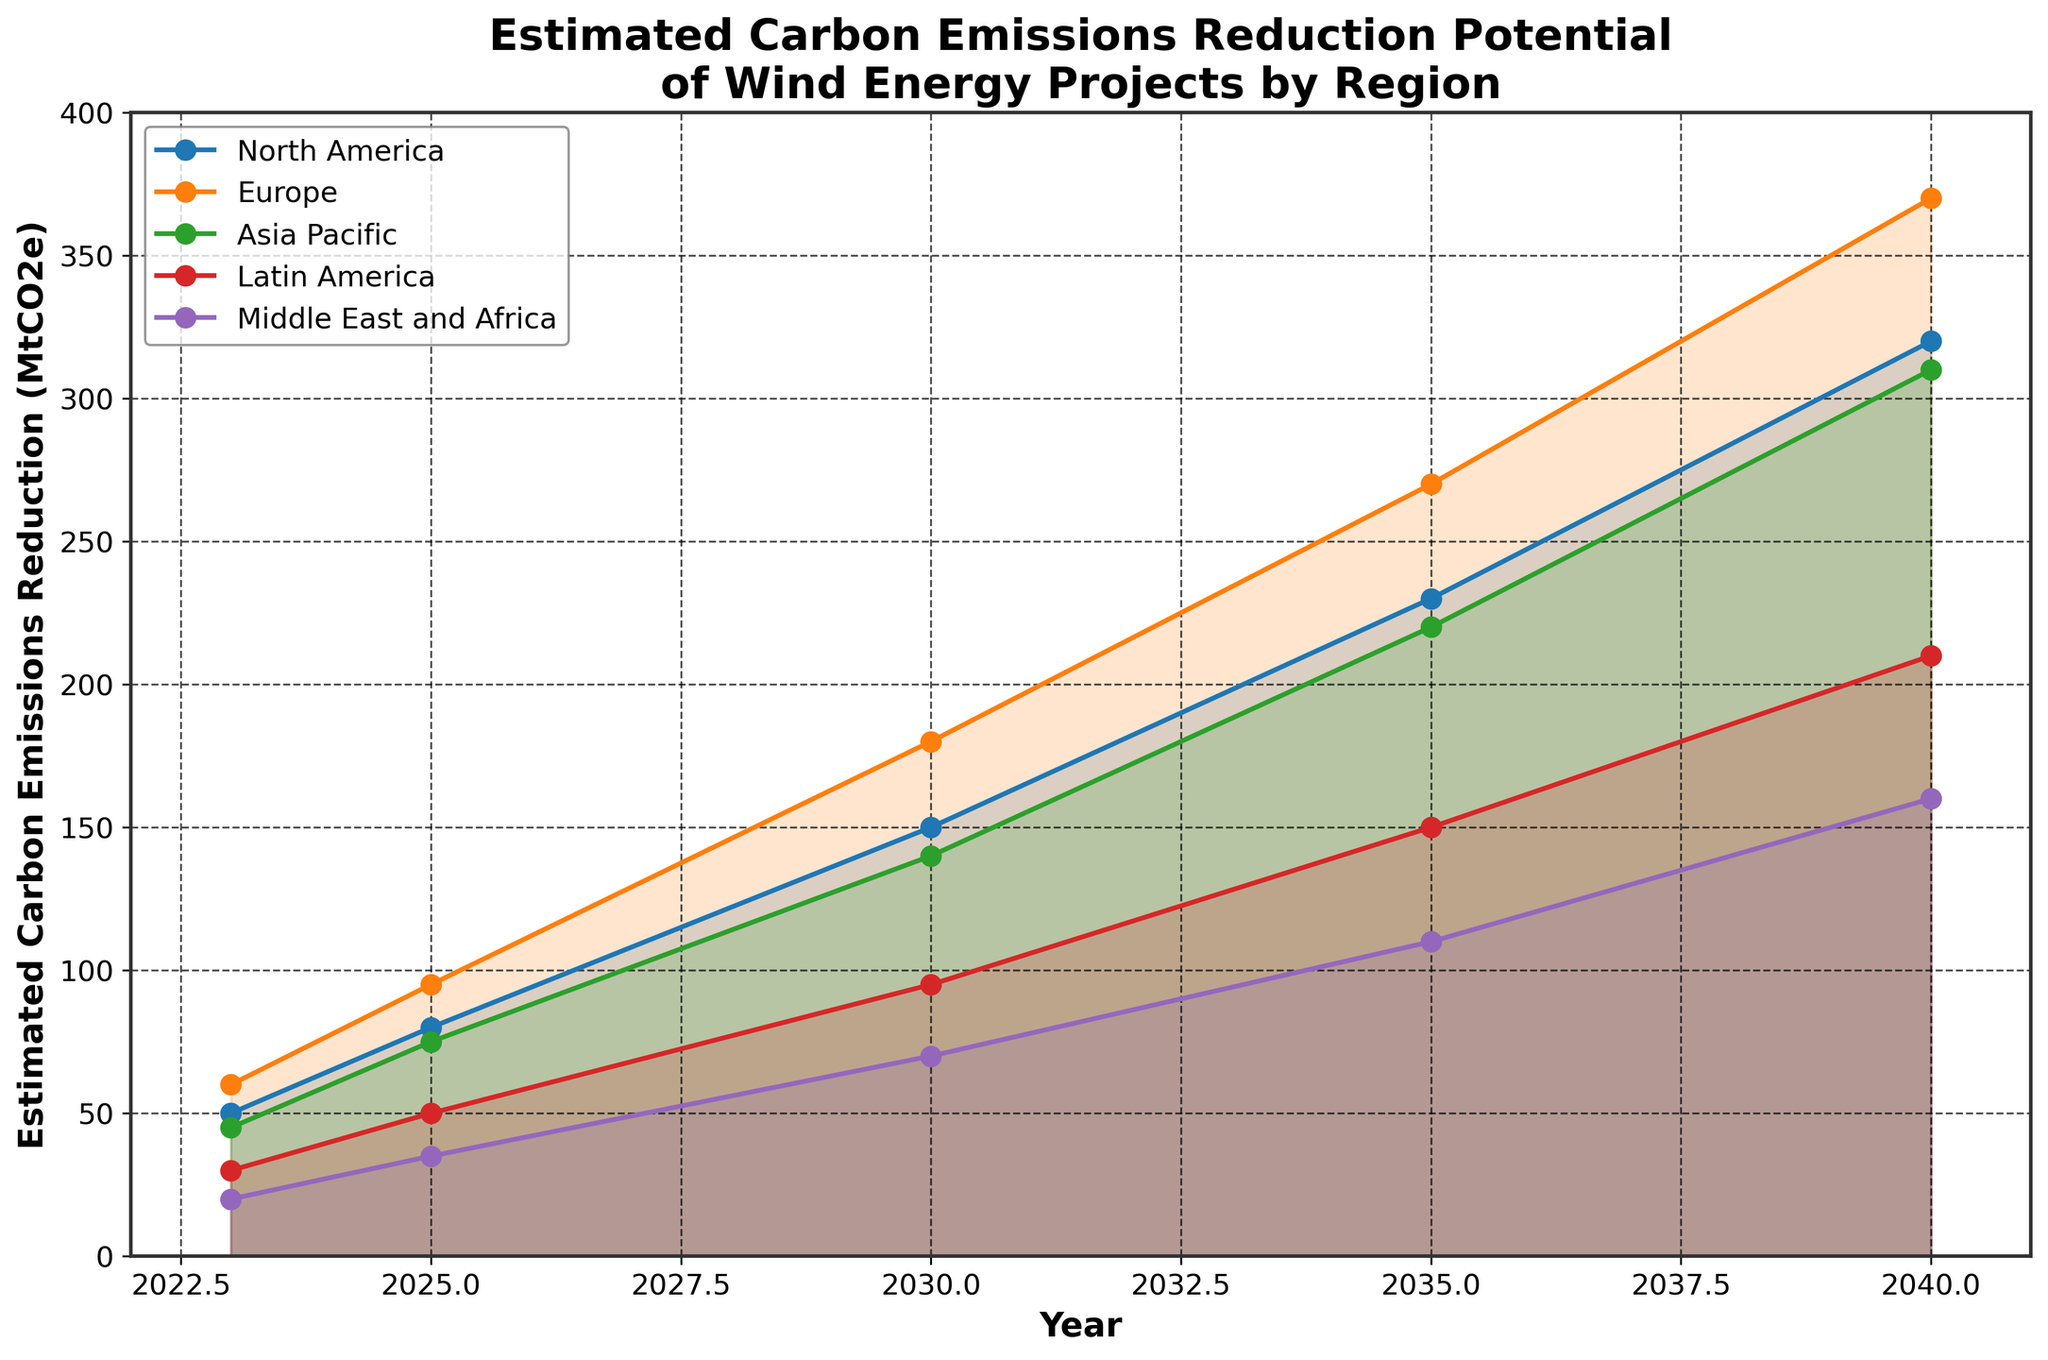What is the estimated carbon emissions reduction in North America in 2025? The figure shows the estimated carbon emissions reduction for North America in different years. Find the value for 2025.
Answer: 80 MtCO2e What is the title of the chart? The title is displayed at the top of the chart, summarizing what the figure represents.
Answer: Estimated Carbon Emissions Reduction Potential of Wind Energy Projects by Region How does the estimated reduction in Asia Pacific in 2030 compare to that in Latin America in the same year? Find the values of the estimated reduction for both Asia Pacific and Latin America in 2030 and compare them. Asia Pacific: 140 MtCO2e, Latin America: 95 MtCO2e.
Answer: Asia Pacific's reduction is higher What is the total carbon emissions reduction potential for all regions combined in 2040? Sum the estimated reductions for all regions in 2040. North America: 320, Europe: 370, Asia Pacific: 310, Latin America: 210, Middle East and Africa: 160. Add them up, 320 + 370 + 310 + 210 + 160 = 1370.
Answer: 1370 MtCO2e Which region shows the steepest increase in carbon emissions reduction potential from 2023 to 2040? Calculate the difference in reduction potential from 2023 to 2040 for each region and compare: North America (320 - 50), Europe (370 - 60), Asia Pacific (310 - 45), Latin America (210 - 30), Middle East and Africa (160 - 20).
Answer: Europe In which year does Europe first reach 180 MtCO2e reduction in potential? Look at the values for Europe and find the year when the estimated reduction first reaches or surpasses 180 MtCO2e.
Answer: 2030 What is the difference in estimated reduction between North America and Middle East and Africa in 2040? Subtract the estimated reduction value for Middle East and Africa from that of North America in 2040 (320 - 160).
Answer: 160 MtCO2e Which region has the lowest estimated carbon emissions reduction in 2023? Find the estimated reduction values for all regions in 2023 and compare them.
Answer: Middle East and Africa By how much does the estimated carbon emissions reduction in Latin America increase from 2025 to 2040? Subtract the 2025 value for Latin America from the 2040 value (210 - 50).
Answer: 160 MtCO2e Which regions exceed 200 MtCO2e reduction by 2040? Identify the regions whose values surpass 200 MtCO2e in 2040. North America: 320, Europe: 370, Asia Pacific: 310, Latin America: 210.
Answer: North America, Europe, Asia Pacific, Latin America 